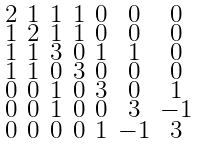Convert formula to latex. <formula><loc_0><loc_0><loc_500><loc_500>\begin{smallmatrix} 2 & 1 & 1 & 1 & 0 & 0 & 0 \\ 1 & 2 & 1 & 1 & 0 & 0 & 0 \\ 1 & 1 & 3 & 0 & 1 & 1 & 0 \\ 1 & 1 & 0 & 3 & 0 & 0 & 0 \\ 0 & 0 & 1 & 0 & 3 & 0 & 1 \\ 0 & 0 & 1 & 0 & 0 & 3 & - 1 \\ 0 & 0 & 0 & 0 & 1 & - 1 & 3 \end{smallmatrix}</formula> 